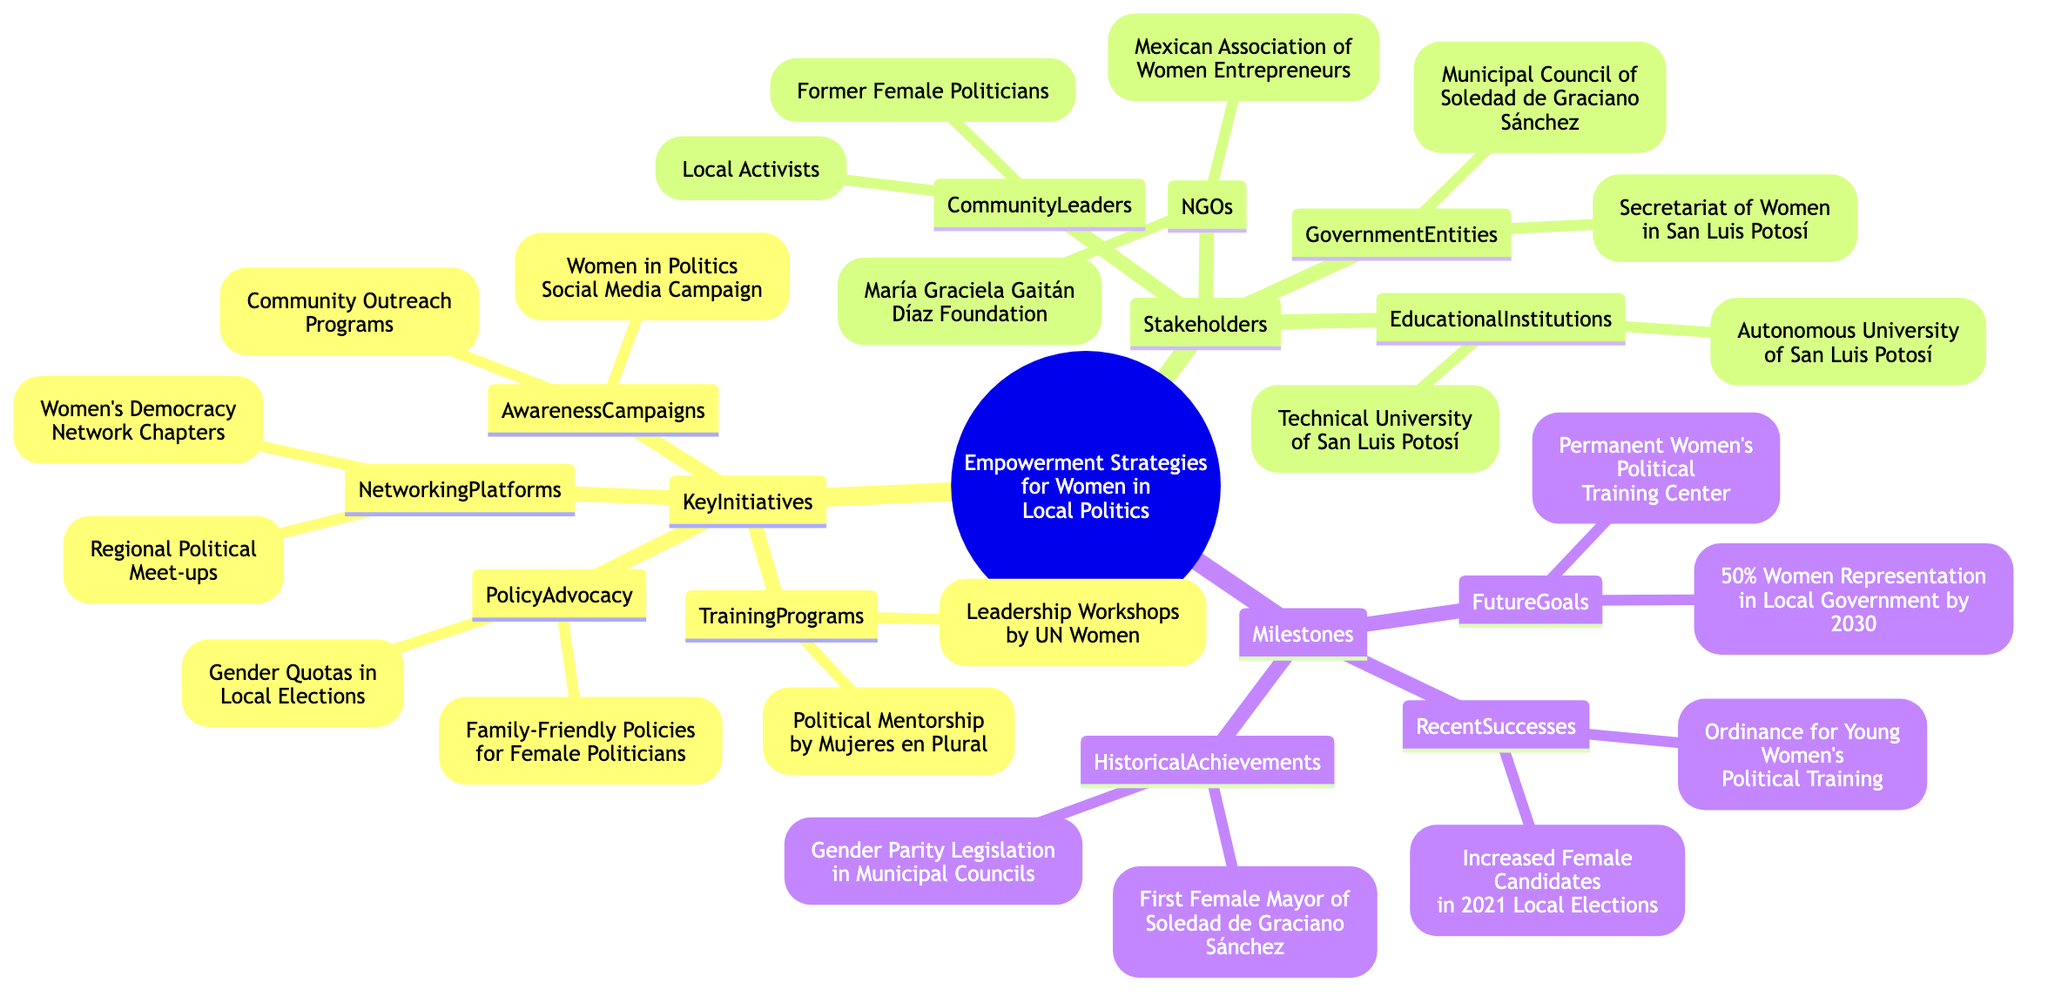What are two key initiatives for women's empowerment in local politics? The diagram lists several key initiatives under "KeyInitiatives." Two examples are "Leadership Workshops by UN Women" and "Political Mentorship by Mujeres en Plural."
Answer: Leadership Workshops by UN Women, Political Mentorship by Mujeres en Plural How many stakeholders are identified in the diagram? The diagram presents four categories of stakeholders: Government Entities, Non-Governmental Organizations, Community Leaders, and Educational Institutions. Each category includes multiple stakeholders. Therefore, the total number of distinct stakeholder categories is four.
Answer: 4 Name one historical achievement regarding women in local politics. Within the "HistoricalAchievements" section, one of the listed milestones is "First Female Mayor of Soledad de Graciano Sánchez, Patricia González." This directly answers the question.
Answer: First Female Mayor of Soledad de Graciano Sánchez, Patricia González What is a future goal mentioned in the diagram? The "FutureGoals" section notes specific goals. One example is "Achieving 50% Women Representation in Local Government by 2030," which reflects a long-term objective for local politics.
Answer: Achieving 50% Women Representation in Local Government by 2030 Which organization is related to  women's entrepreneurship? Under the "NonGovernmentalOrganizations" category, the "Mexican Association of Women Entrepreneurs (AMMJE)" is explicitly mentioned as an organization focused on women's entrepreneurship.
Answer: Mexican Association of Women Entrepreneurs (AMMJE) 